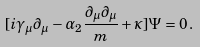<formula> <loc_0><loc_0><loc_500><loc_500>[ i \gamma _ { \mu } \partial _ { \mu } - \alpha _ { 2 } \frac { \partial _ { \mu } \partial _ { \mu } } { m } + \kappa ] \Psi = 0 \, .</formula> 